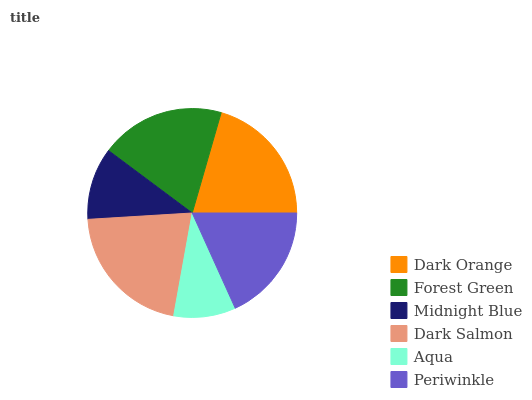Is Aqua the minimum?
Answer yes or no. Yes. Is Dark Salmon the maximum?
Answer yes or no. Yes. Is Forest Green the minimum?
Answer yes or no. No. Is Forest Green the maximum?
Answer yes or no. No. Is Dark Orange greater than Forest Green?
Answer yes or no. Yes. Is Forest Green less than Dark Orange?
Answer yes or no. Yes. Is Forest Green greater than Dark Orange?
Answer yes or no. No. Is Dark Orange less than Forest Green?
Answer yes or no. No. Is Forest Green the high median?
Answer yes or no. Yes. Is Periwinkle the low median?
Answer yes or no. Yes. Is Midnight Blue the high median?
Answer yes or no. No. Is Dark Salmon the low median?
Answer yes or no. No. 